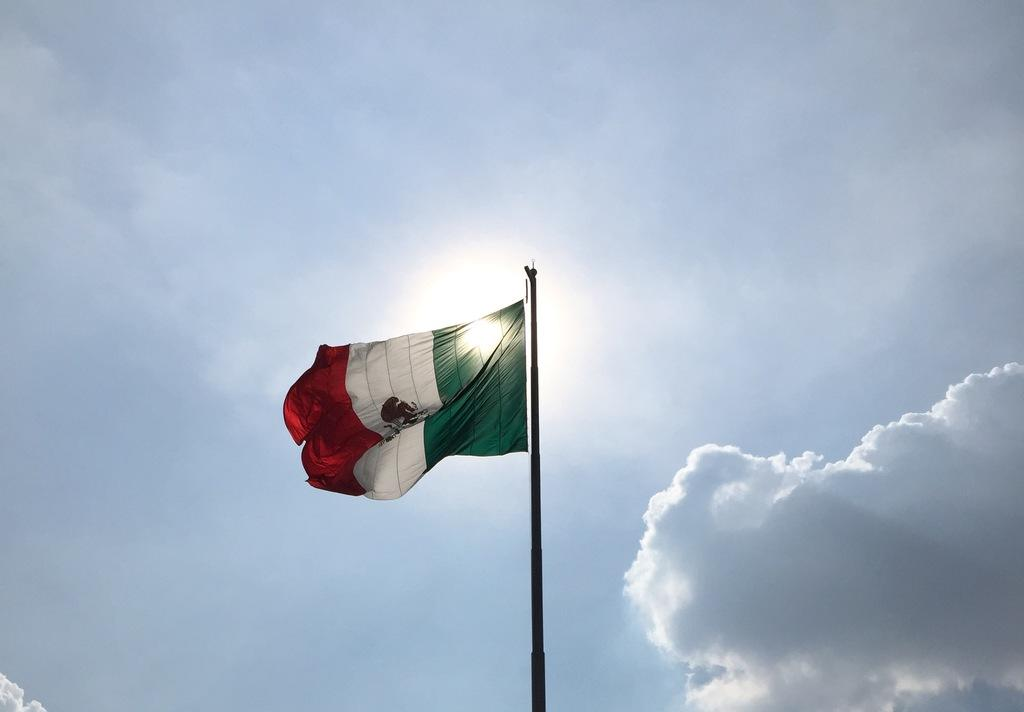What is on the pole in the image? There is a flag on a pole in the image. What colors are present on the flag? The flag has colors orange, white, green, and black. What is visible at the top of the image? The sky is visible at the top of the image. What can be seen in the sky? There are clouds and the sun visible in the sky. Why is the flag crying in the image? The flag is not crying in the image; it is a non-living object and does not have emotions or the ability to cry. 